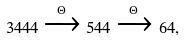<formula> <loc_0><loc_0><loc_500><loc_500>3 4 4 4 \xrightarrow { \Theta } 5 4 4 \xrightarrow { \Theta } 6 4 ,</formula> 